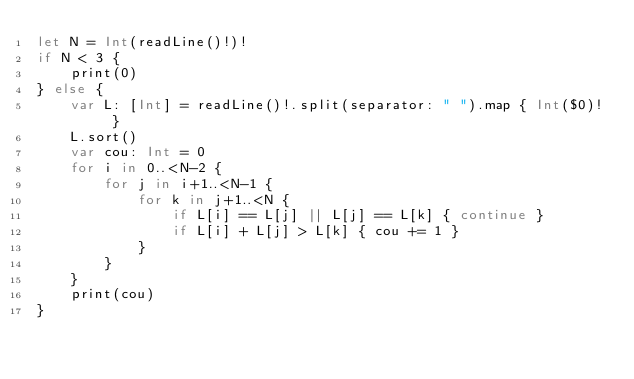<code> <loc_0><loc_0><loc_500><loc_500><_Swift_>let N = Int(readLine()!)!
if N < 3 {
    print(0)
} else {
    var L: [Int] = readLine()!.split(separator: " ").map { Int($0)! }
    L.sort()
    var cou: Int = 0
    for i in 0..<N-2 {
        for j in i+1..<N-1 {
            for k in j+1..<N {
                if L[i] == L[j] || L[j] == L[k] { continue }
                if L[i] + L[j] > L[k] { cou += 1 }
            }
        }
    }
    print(cou)
}</code> 